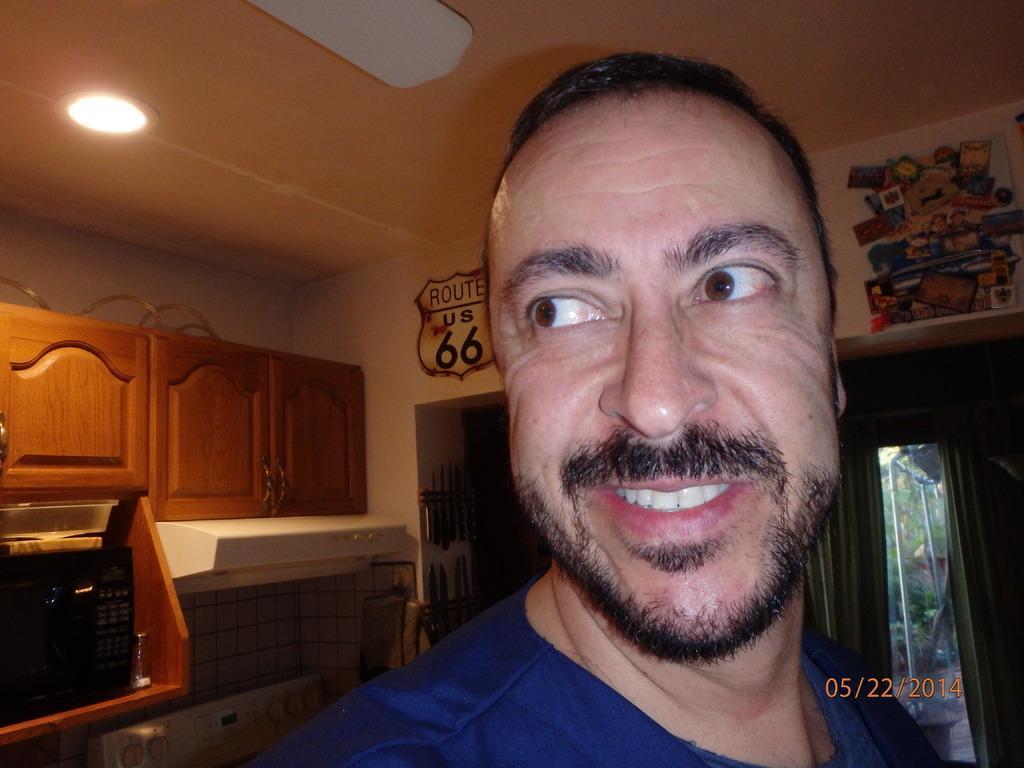How would you summarize this image in a sentence or two? In this picture we can see a man smiling. In the background we can see cupboards, microwave oven, jar, ceiling, light, posters, poles, trees, knives, walls and some objects. 